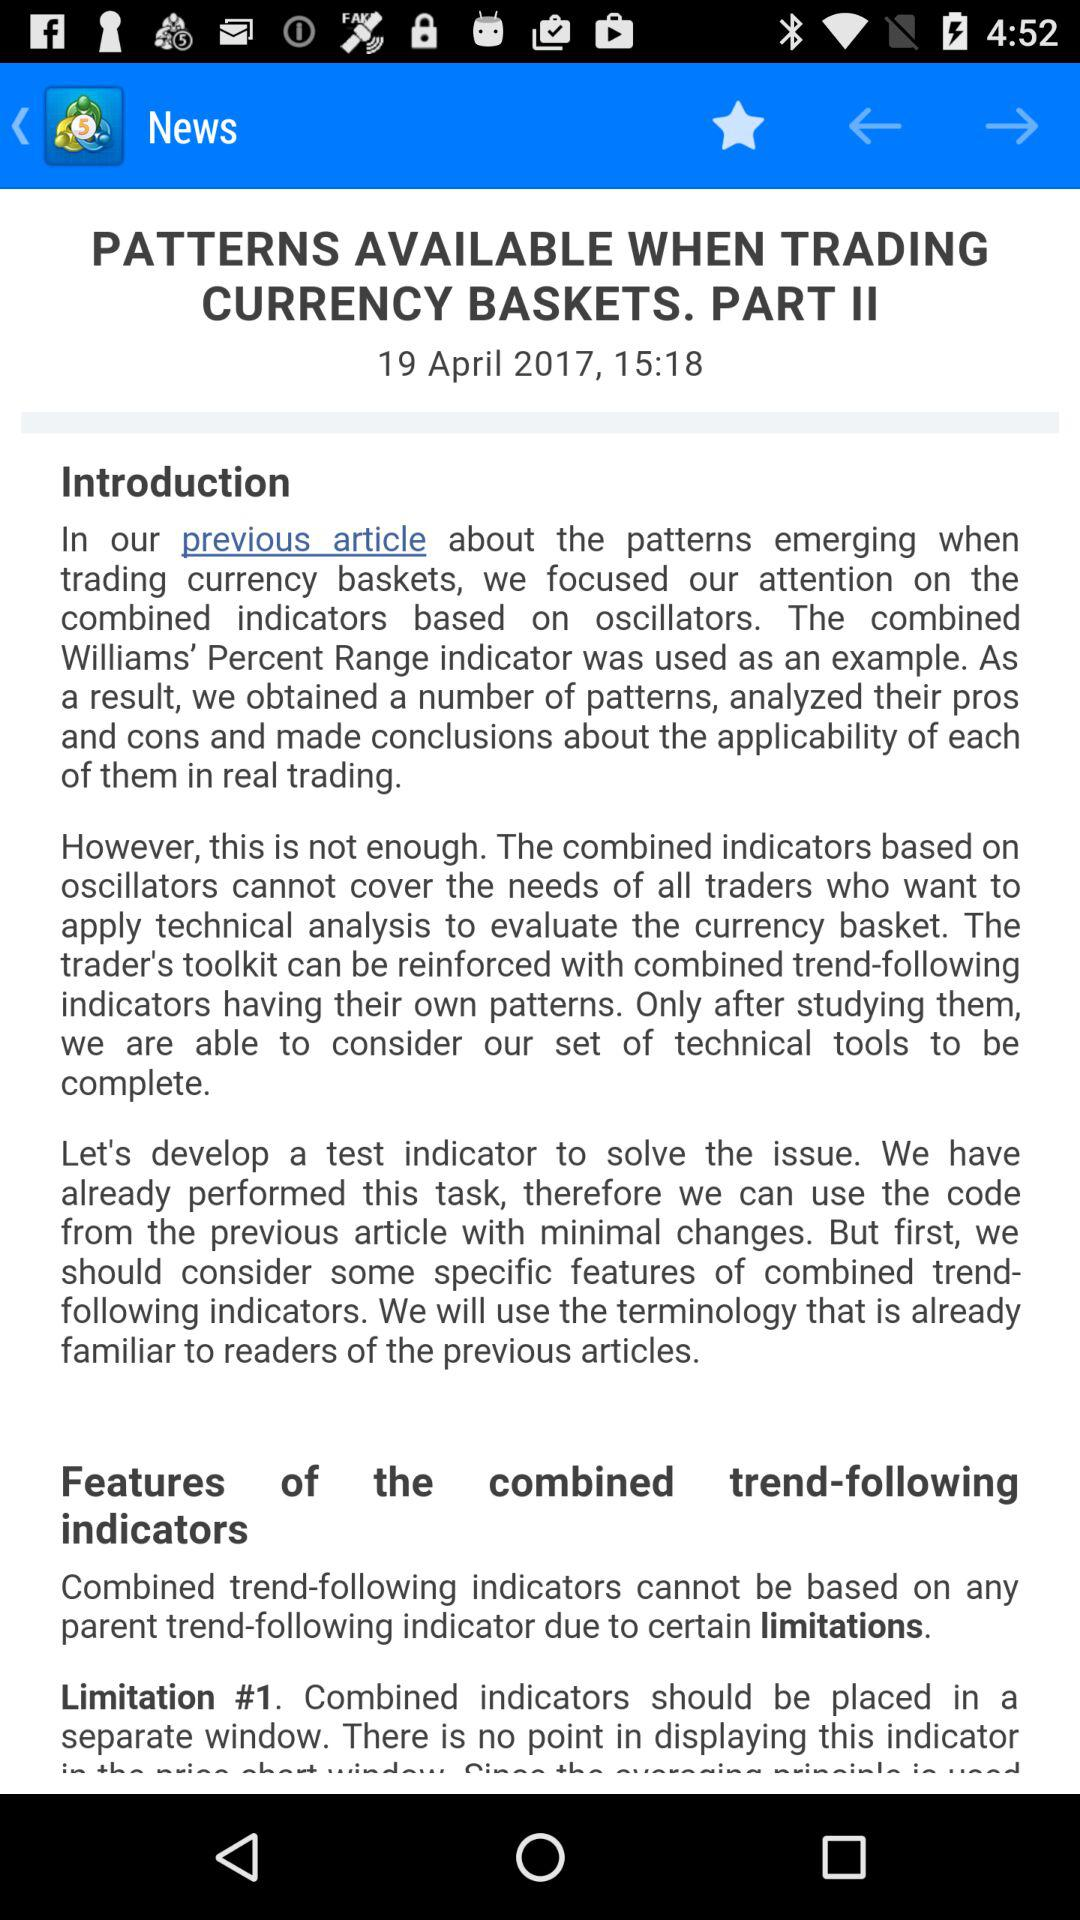What is the article name? The article name is "PATTERNS AVAILABLE WHEN TRADING CURRENCY BASKETS. PART II". 